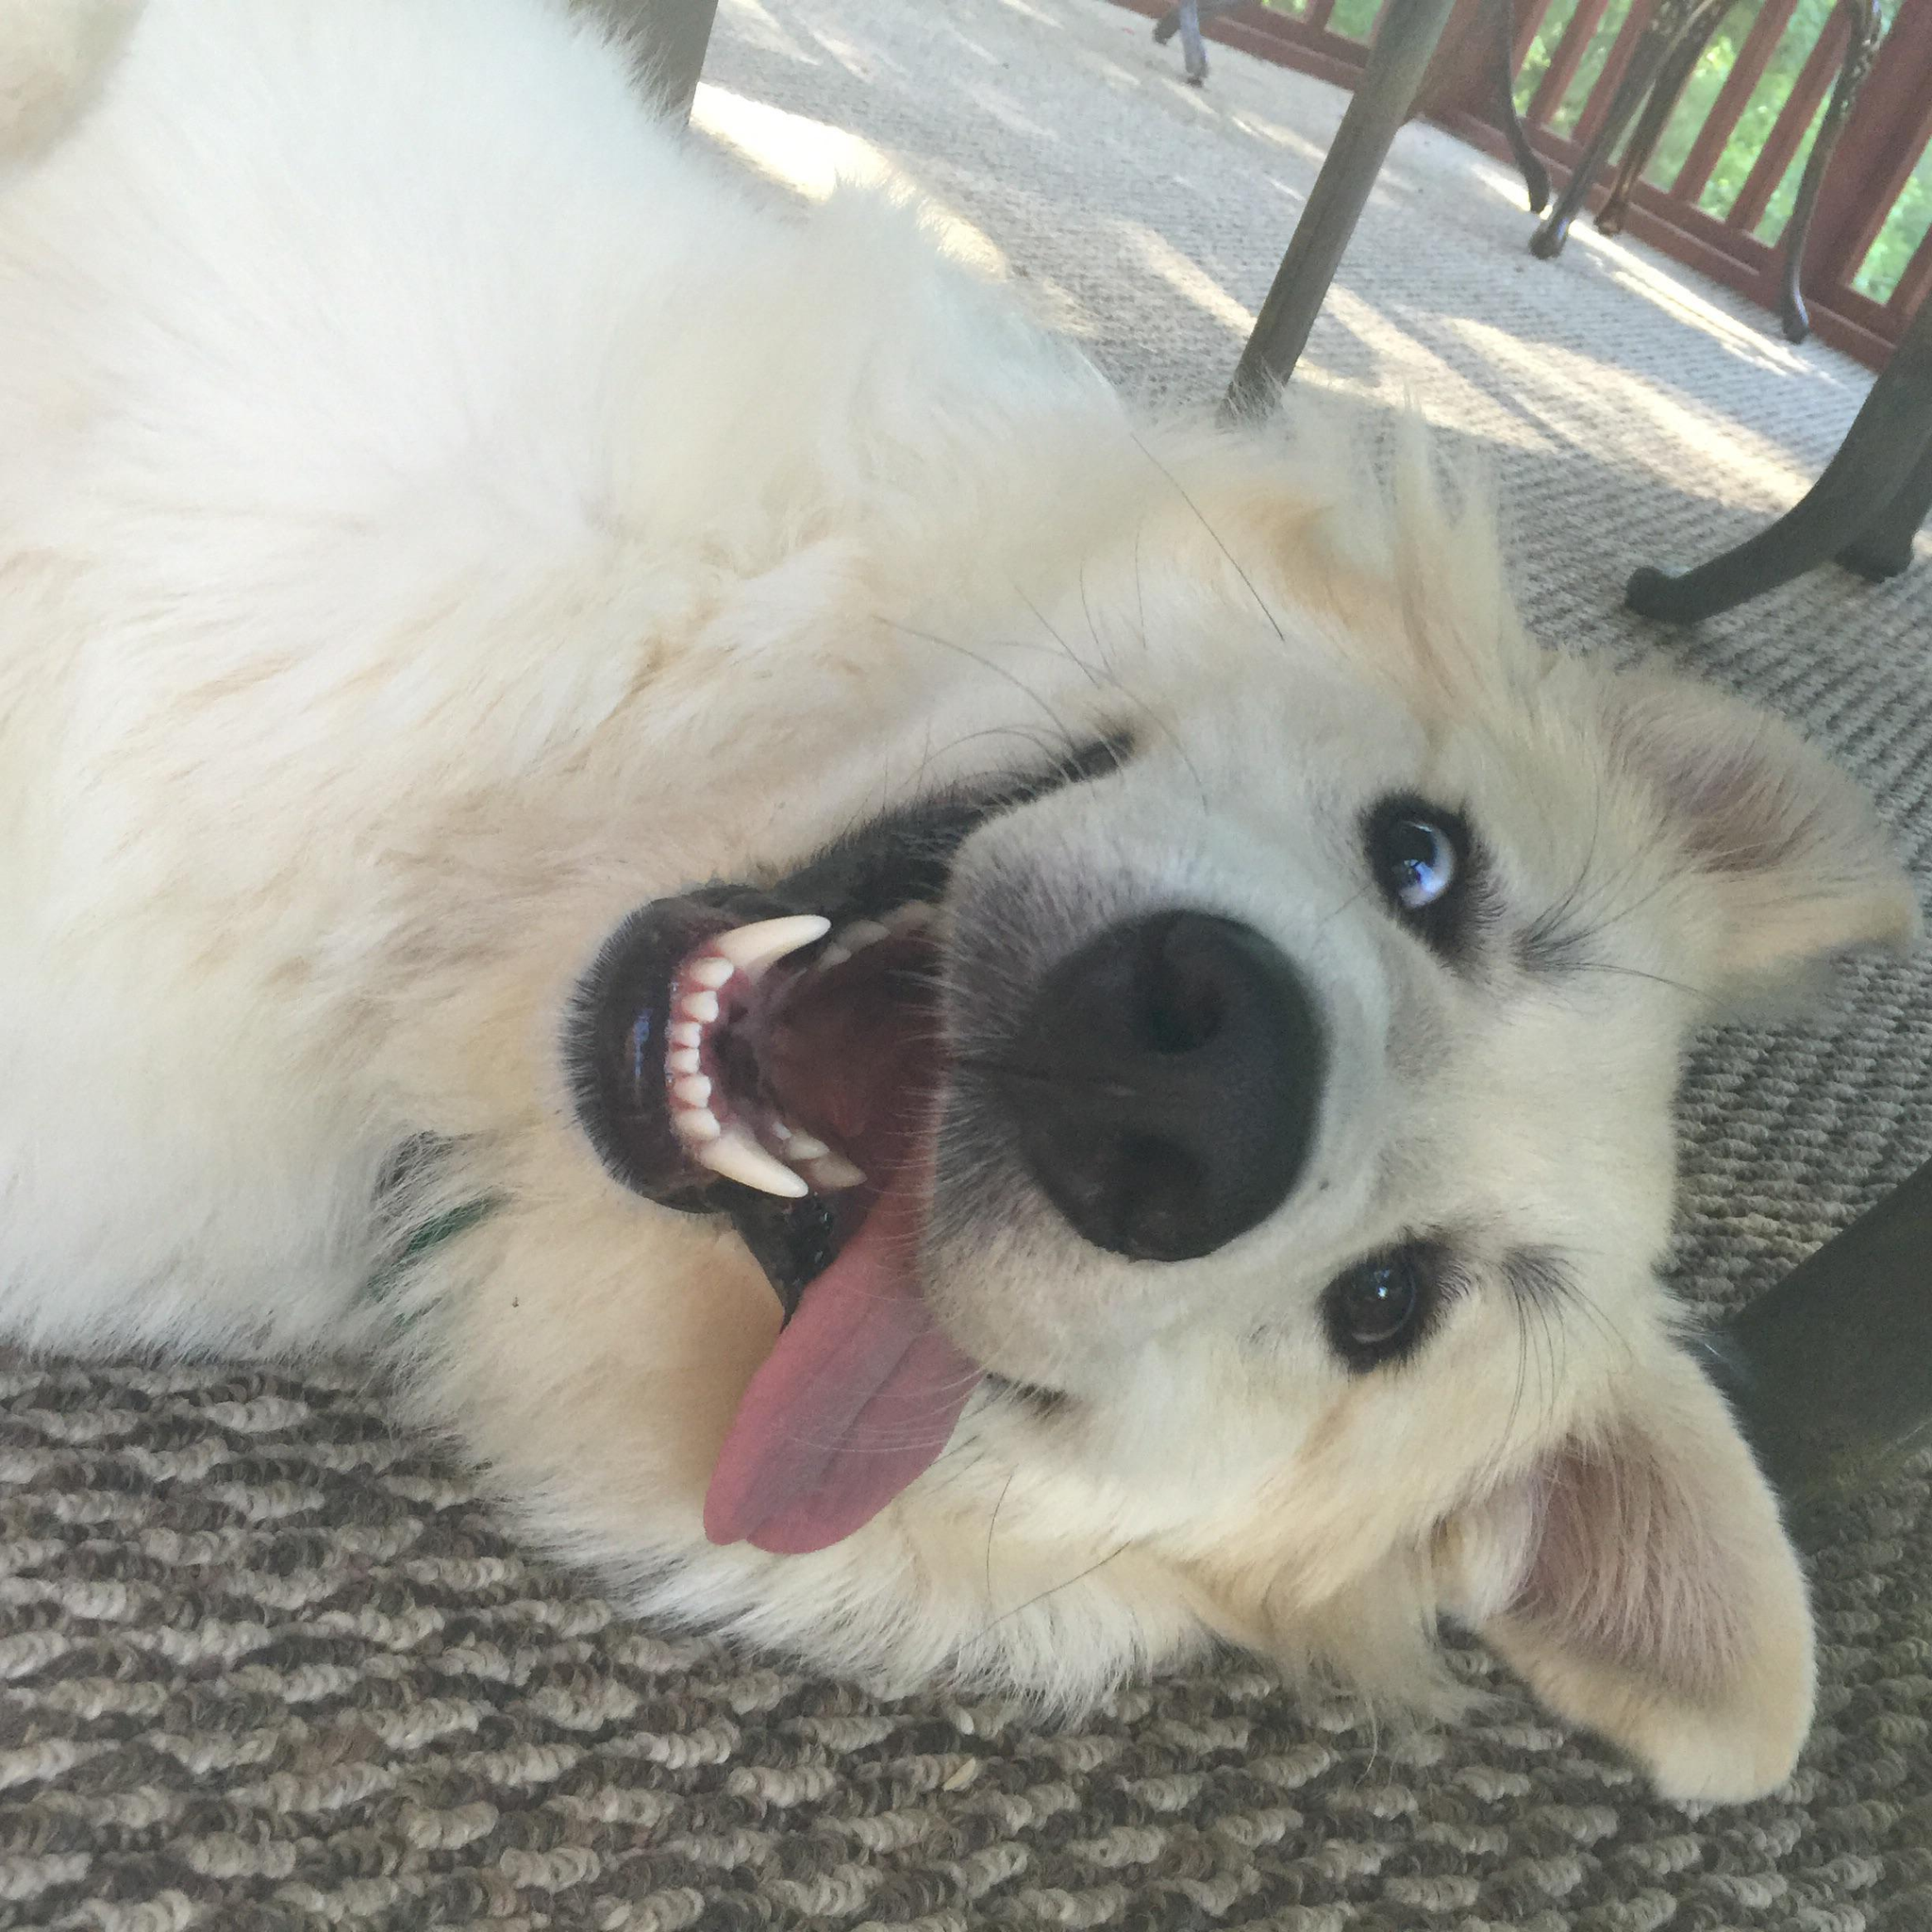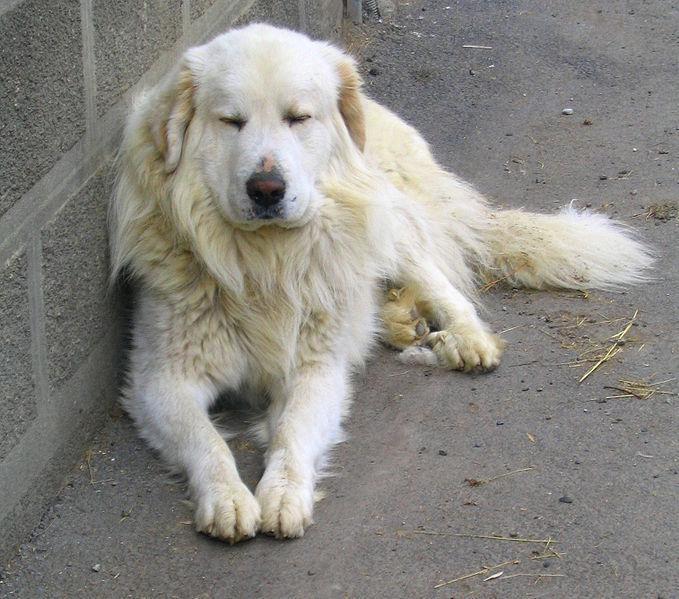The first image is the image on the left, the second image is the image on the right. Given the left and right images, does the statement "at least one dog is on a grass surface" hold true? Answer yes or no. No. The first image is the image on the left, the second image is the image on the right. For the images shown, is this caption "One dog's mouth is open." true? Answer yes or no. Yes. 